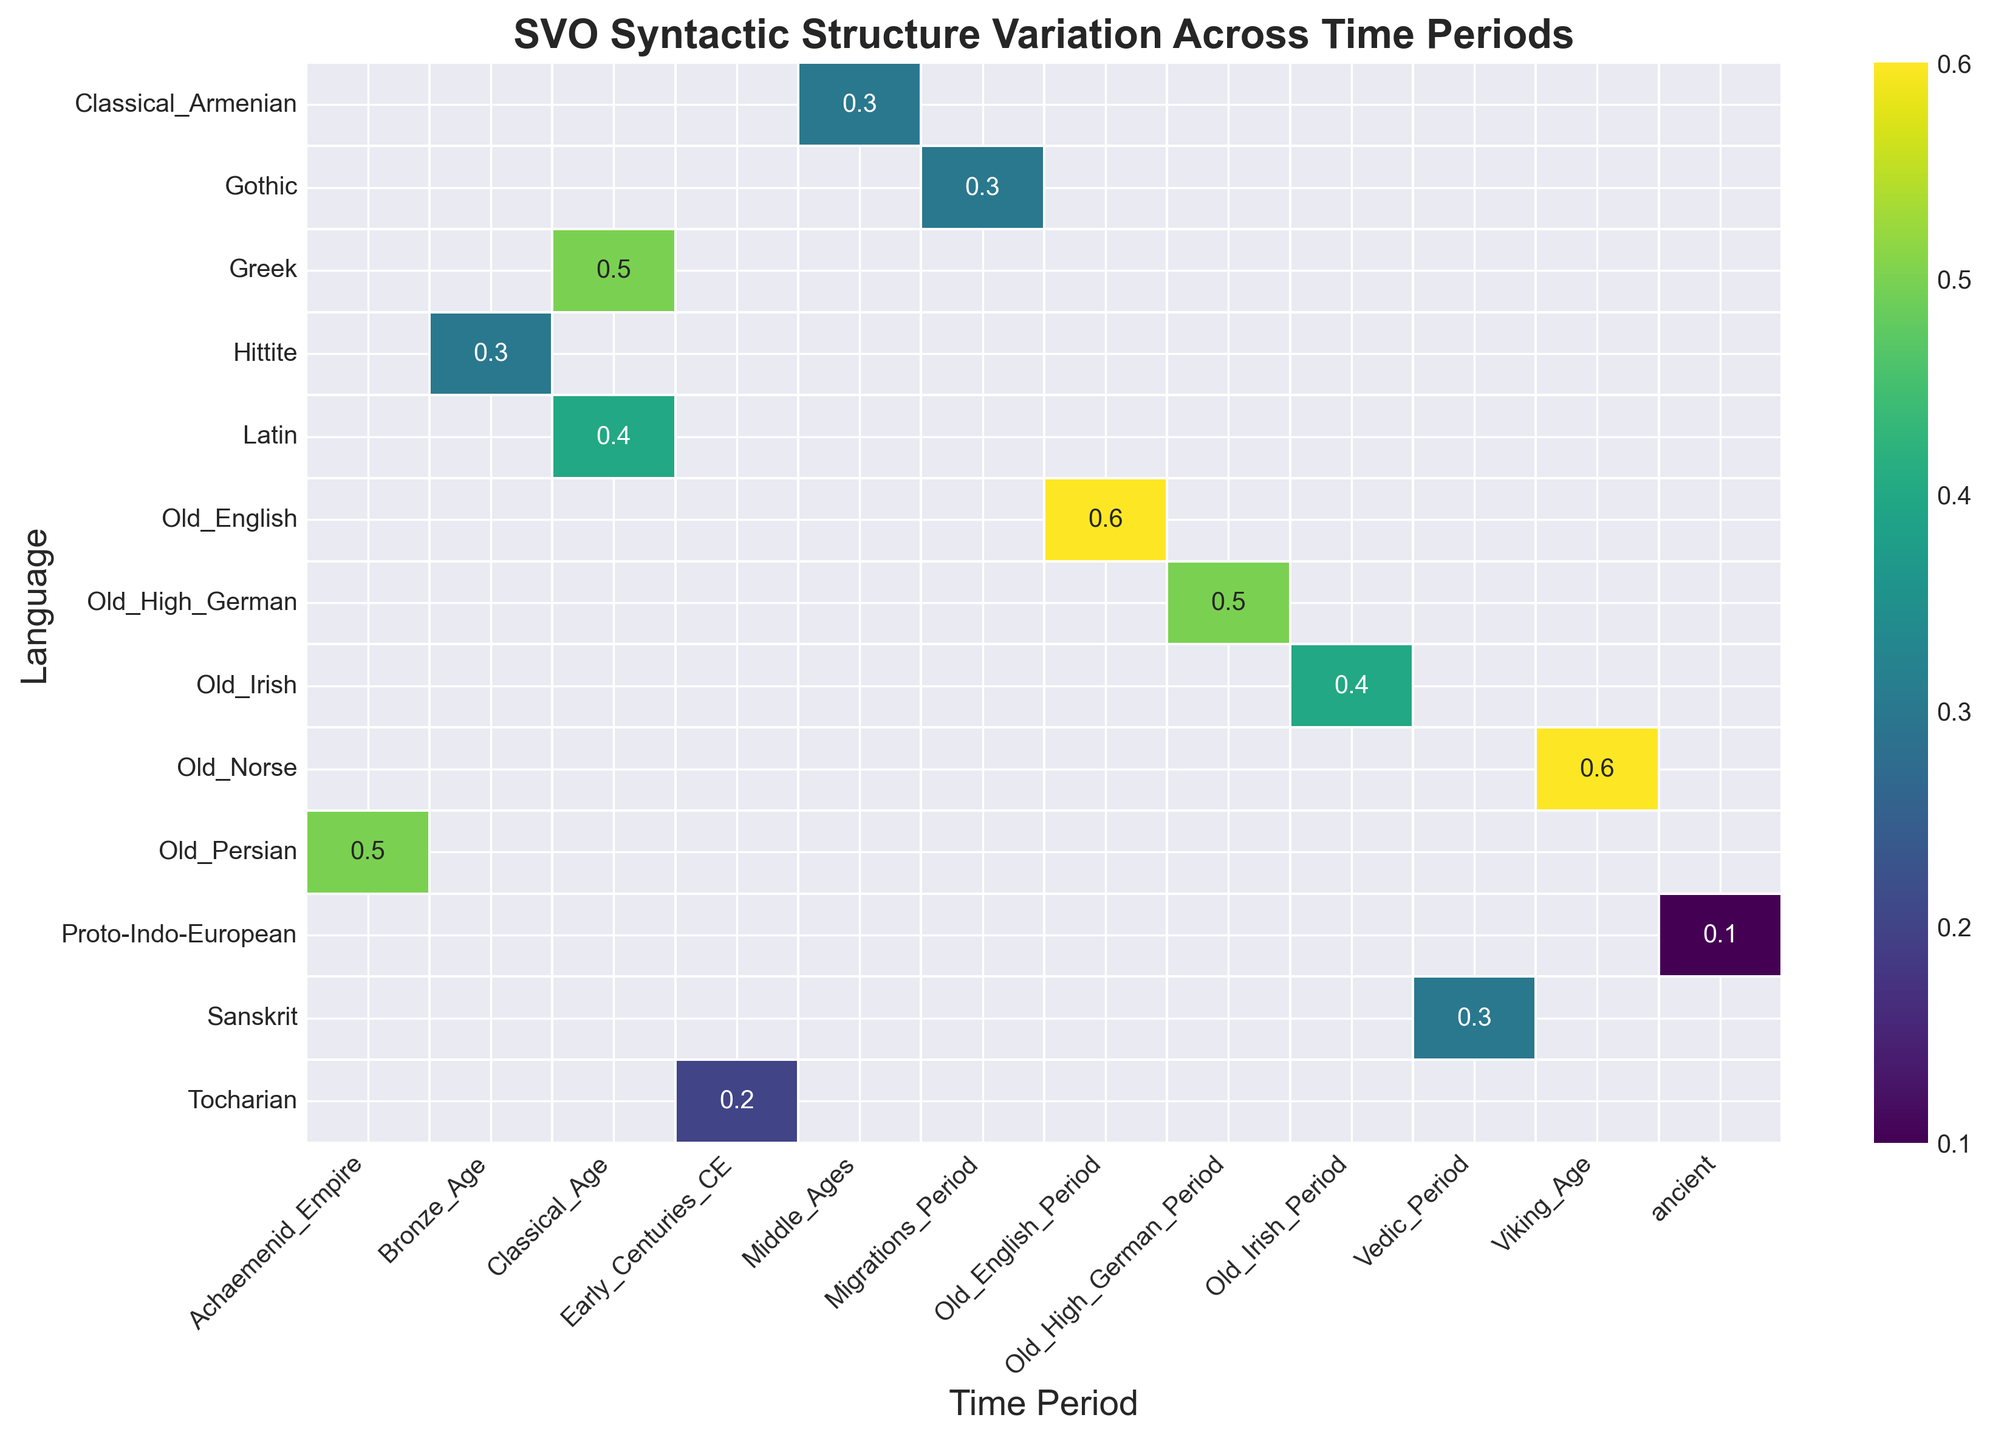Which language shows the highest SVO percentage in its time period? Look for the highest numerical value in the heatmap and identify the corresponding language.
Answer: Old English Which time period seems to have the most diverse SVO values based on color variation? Identify the time period column with the most variation in colors. Different shades in the heatmap indicate variability.
Answer: Classical Age How does the SVO percentage for Latin compare to Greek in the Classical Age? Locate both Latin and Greek in the Classical Age column and compare their values. Latin shows a 0.4 SVO percentage while Greek shows a 0.5.
Answer: Greek Identify which language has the least SVO percentage in its time period. Look for the lowest numerical value in the heatmap and identify the corresponding language.
Answer: Proto-Indo-European Does Tocharian have a higher SVO percentage than Old High German? Compare the values of Tocharian and Old High German in their respective time periods. Tocharian has 0.2, while Old High German has 0.5.
Answer: No What is the sum of the SVO percentages for Old English and Old Norse? Add the SVO percentages of Old English (0.6) and Old Norse (0.6).
Answer: 1.2 Which geographical region has the highest variation in SVO percentages among languages listed? Compare the ranges of SVO percentages of languages within each geographical region.
Answer: Western Europe Count how many languages have an SVO percentage of 0.4 or greater. Identify and count all the languages with an SVO percentage of 0.4 or higher from the heatmap.
Answer: Four Compare the average SVO percentage of languages during the Old English Period and the Viking Age. Calculate the average SVO for languages in both the Old English Period (Old English) and the Viking Age (Old Norse). Old English has 0.6, and Old Norse has 0.6. The average for both periods is 0.6.
Answer: Equal Which time period has the least number of languages with SVO data? Identify the column with the fewest annotations. Logical Old English Period appears to have one language data point.
Answer: Old English Period 